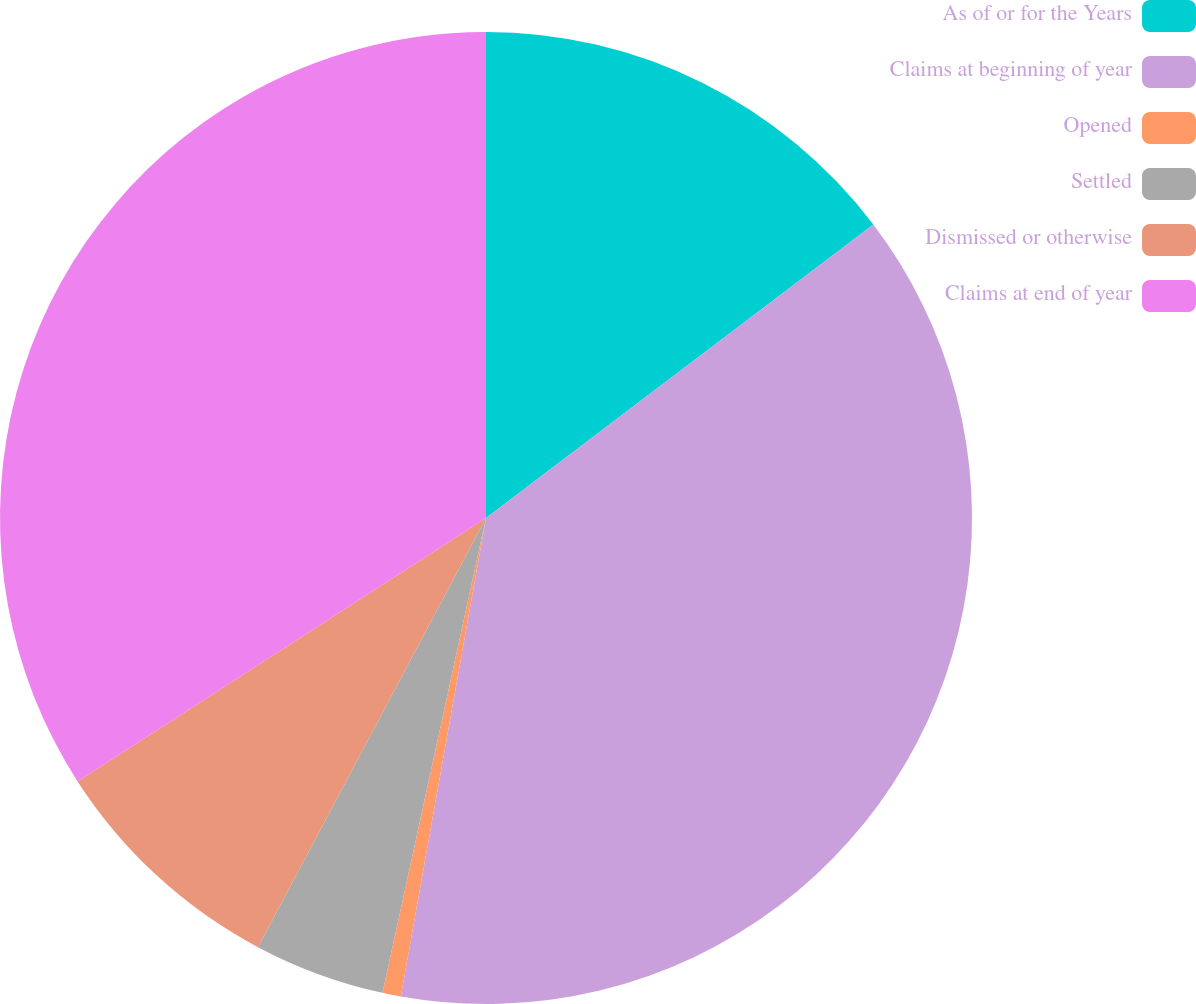<chart> <loc_0><loc_0><loc_500><loc_500><pie_chart><fcel>As of or for the Years<fcel>Claims at beginning of year<fcel>Opened<fcel>Settled<fcel>Dismissed or otherwise<fcel>Claims at end of year<nl><fcel>14.68%<fcel>38.13%<fcel>0.61%<fcel>4.36%<fcel>8.11%<fcel>34.12%<nl></chart> 